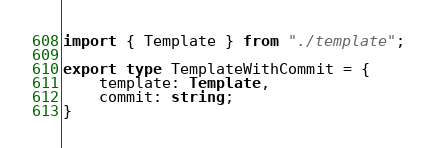<code> <loc_0><loc_0><loc_500><loc_500><_TypeScript_>import { Template } from "./template";

export type TemplateWithCommit = {
    template: Template,
    commit: string;
}</code> 